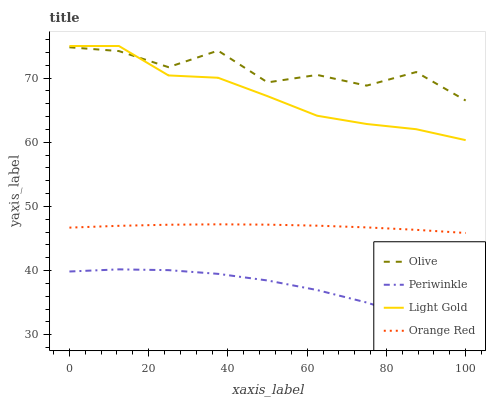Does Light Gold have the minimum area under the curve?
Answer yes or no. No. Does Light Gold have the maximum area under the curve?
Answer yes or no. No. Is Light Gold the smoothest?
Answer yes or no. No. Is Light Gold the roughest?
Answer yes or no. No. Does Light Gold have the lowest value?
Answer yes or no. No. Does Periwinkle have the highest value?
Answer yes or no. No. Is Periwinkle less than Orange Red?
Answer yes or no. Yes. Is Orange Red greater than Periwinkle?
Answer yes or no. Yes. Does Periwinkle intersect Orange Red?
Answer yes or no. No. 